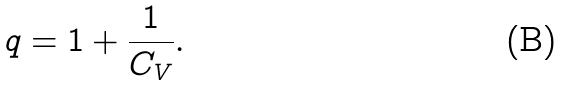Convert formula to latex. <formula><loc_0><loc_0><loc_500><loc_500>q = 1 + \frac { 1 } { C _ { V } } .</formula> 